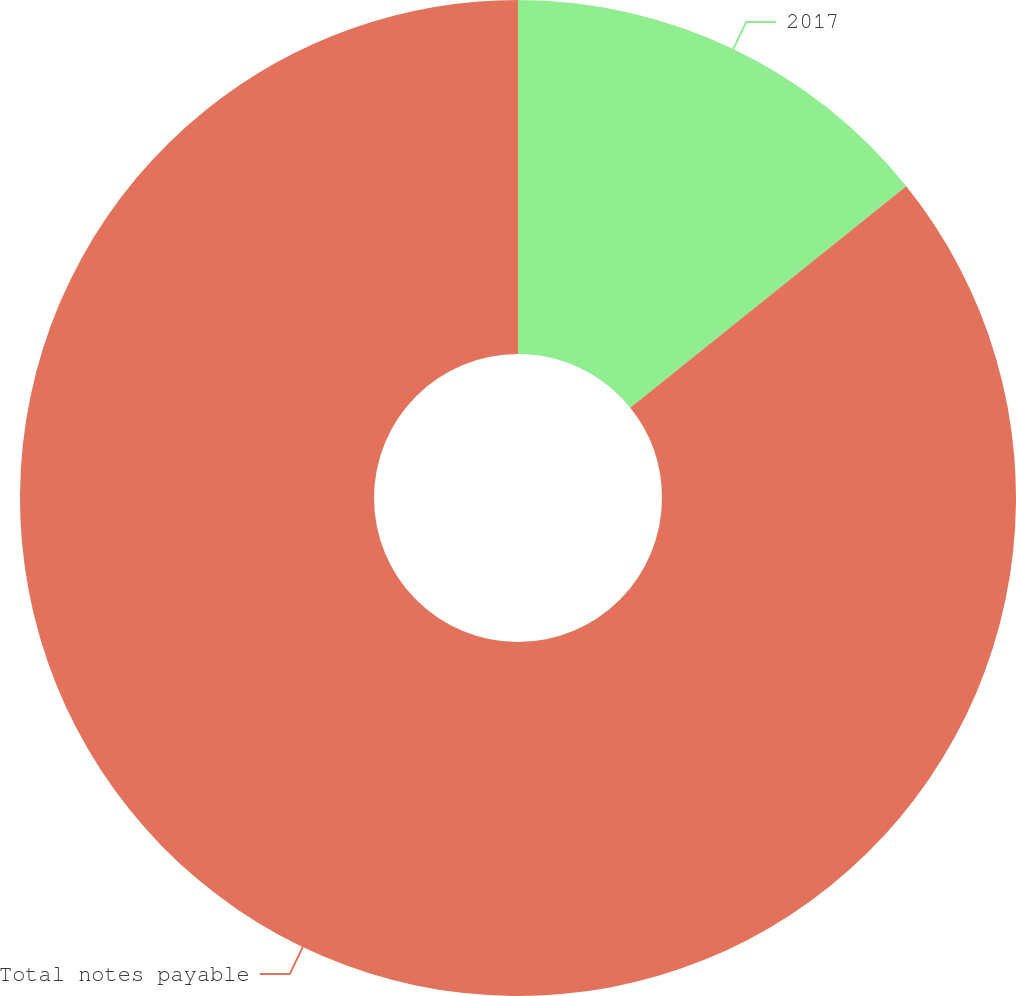<chart> <loc_0><loc_0><loc_500><loc_500><pie_chart><fcel>2017<fcel>Total notes payable<nl><fcel>14.23%<fcel>85.77%<nl></chart> 